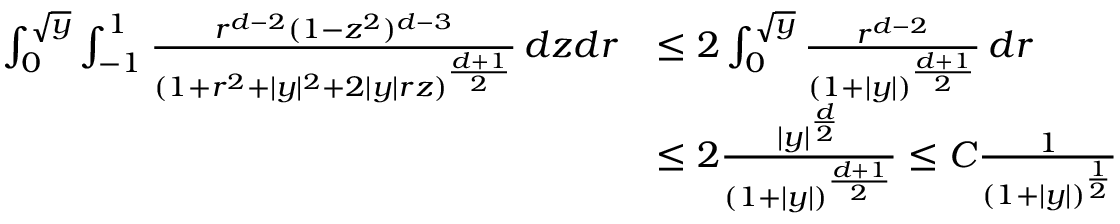Convert formula to latex. <formula><loc_0><loc_0><loc_500><loc_500>\begin{array} { r l } { \int _ { 0 } ^ { \sqrt { y } } \int _ { - 1 } ^ { 1 } \frac { r ^ { d - 2 } ( 1 - z ^ { 2 } ) ^ { d - 3 } } { ( 1 + r ^ { 2 } + | y | ^ { 2 } + 2 | y | r z ) ^ { \frac { d + 1 } { 2 } } } \, d z d r } & { \leq 2 \int _ { 0 } ^ { \sqrt { y } } \frac { r ^ { d - 2 } } { ( 1 + | y | ) ^ { \frac { d + 1 } { 2 } } } \, d r } \\ & { \leq 2 \frac { | y | ^ { \frac { d } { 2 } } } { ( 1 + | y | ) ^ { \frac { d + 1 } { 2 } } } \leq C \frac { 1 } { ( 1 + | y | ) ^ { \frac { 1 } { 2 } } } } \end{array}</formula> 